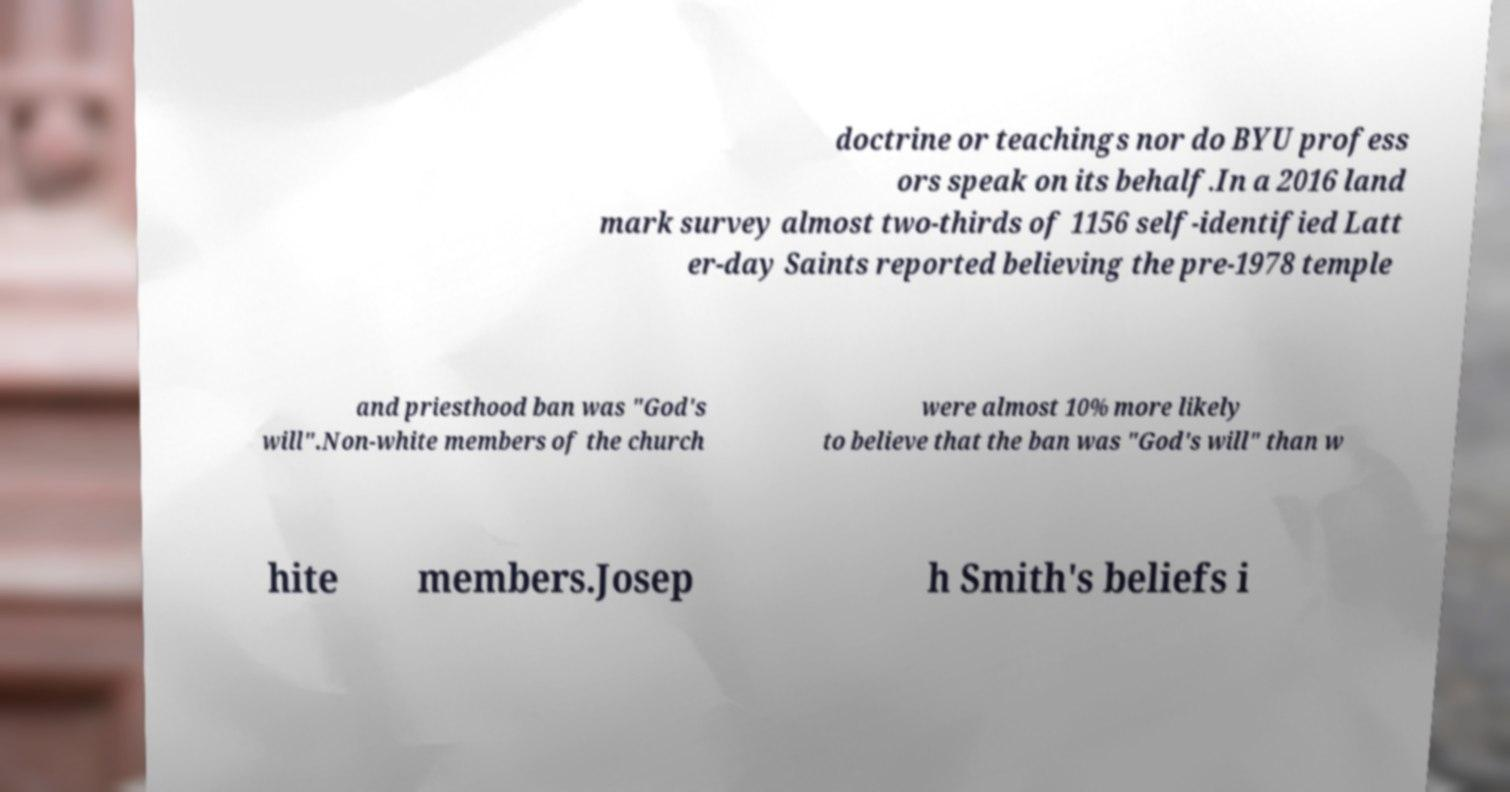Can you accurately transcribe the text from the provided image for me? doctrine or teachings nor do BYU profess ors speak on its behalf.In a 2016 land mark survey almost two-thirds of 1156 self-identified Latt er-day Saints reported believing the pre-1978 temple and priesthood ban was "God's will".Non-white members of the church were almost 10% more likely to believe that the ban was "God's will" than w hite members.Josep h Smith's beliefs i 